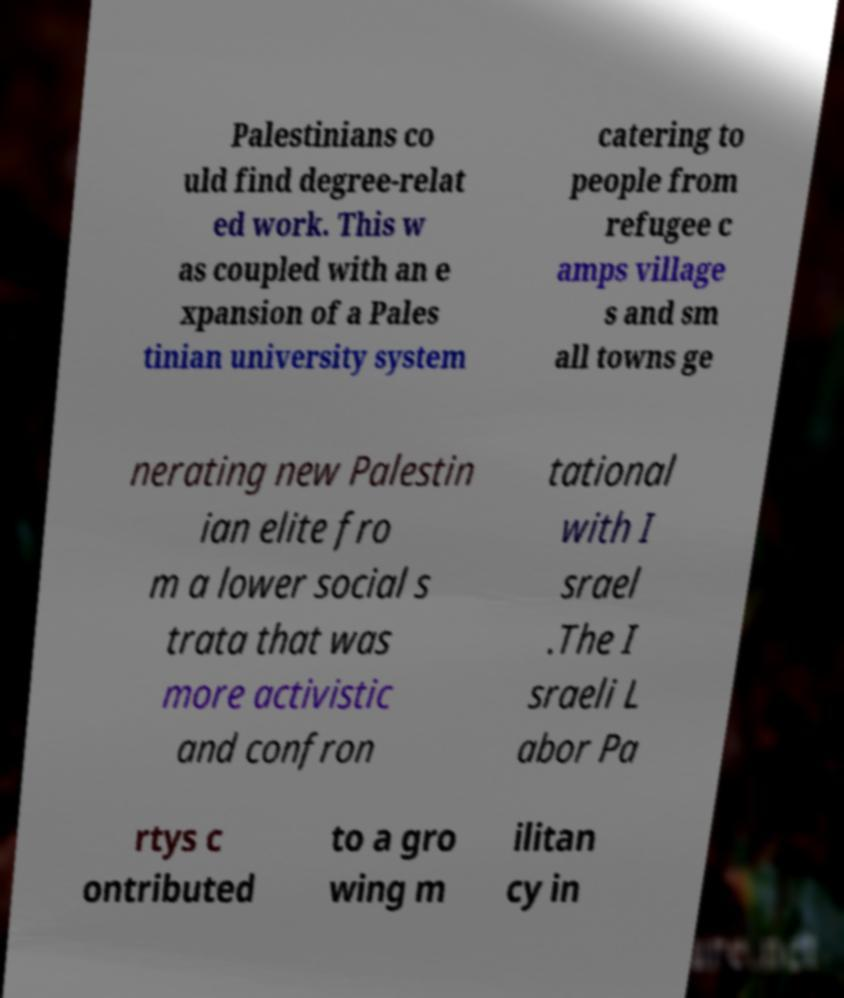Please read and relay the text visible in this image. What does it say? Palestinians co uld find degree-relat ed work. This w as coupled with an e xpansion of a Pales tinian university system catering to people from refugee c amps village s and sm all towns ge nerating new Palestin ian elite fro m a lower social s trata that was more activistic and confron tational with I srael .The I sraeli L abor Pa rtys c ontributed to a gro wing m ilitan cy in 